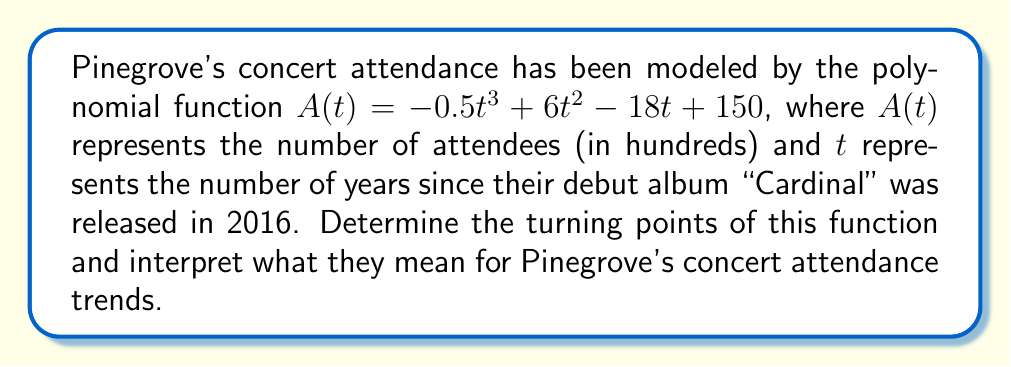Teach me how to tackle this problem. To find the turning points of the polynomial function, we need to follow these steps:

1) First, we need to find the derivative of $A(t)$:
   $A'(t) = -1.5t^2 + 12t - 18$

2) The turning points occur where $A'(t) = 0$, so we need to solve this equation:
   $-1.5t^2 + 12t - 18 = 0$

3) This is a quadratic equation. We can solve it using the quadratic formula:
   $t = \frac{-b \pm \sqrt{b^2 - 4ac}}{2a}$

   Where $a = -1.5$, $b = 12$, and $c = -18$

4) Substituting these values:
   $t = \frac{-12 \pm \sqrt{12^2 - 4(-1.5)(-18)}}{2(-1.5)}$
   $= \frac{-12 \pm \sqrt{144 - 108}}{-3}$
   $= \frac{-12 \pm \sqrt{36}}{-3}$
   $= \frac{-12 \pm 6}{-3}$

5) This gives us two solutions:
   $t_1 = \frac{-12 + 6}{-3} = 2$ and $t_2 = \frac{-12 - 6}{-3} = 6$

6) To find the corresponding $A(t)$ values, we substitute these $t$ values back into the original function:

   For $t_1 = 2$:
   $A(2) = -0.5(2)^3 + 6(2)^2 - 18(2) + 150 = -4 + 24 - 36 + 150 = 134$

   For $t_2 = 6$:
   $A(6) = -0.5(6)^3 + 6(6)^2 - 18(6) + 150 = -108 + 216 - 108 + 150 = 150$

Therefore, the turning points are (2, 134) and (6, 150).

Interpretation: The first turning point (2, 134) occurs 2 years after the release of "Cardinal", in 2018. This represents a local maximum, indicating that Pinegrove's concert attendance peaked at about 13,400 attendees. The second turning point (6, 150) occurs 6 years after "Cardinal", in 2022. This represents a local minimum, with attendance dropping to 15,000 before potentially rising again.
Answer: The turning points are (2, 134) and (6, 150), representing a local maximum in 2018 with 13,400 attendees and a local minimum in 2022 with 15,000 attendees. 